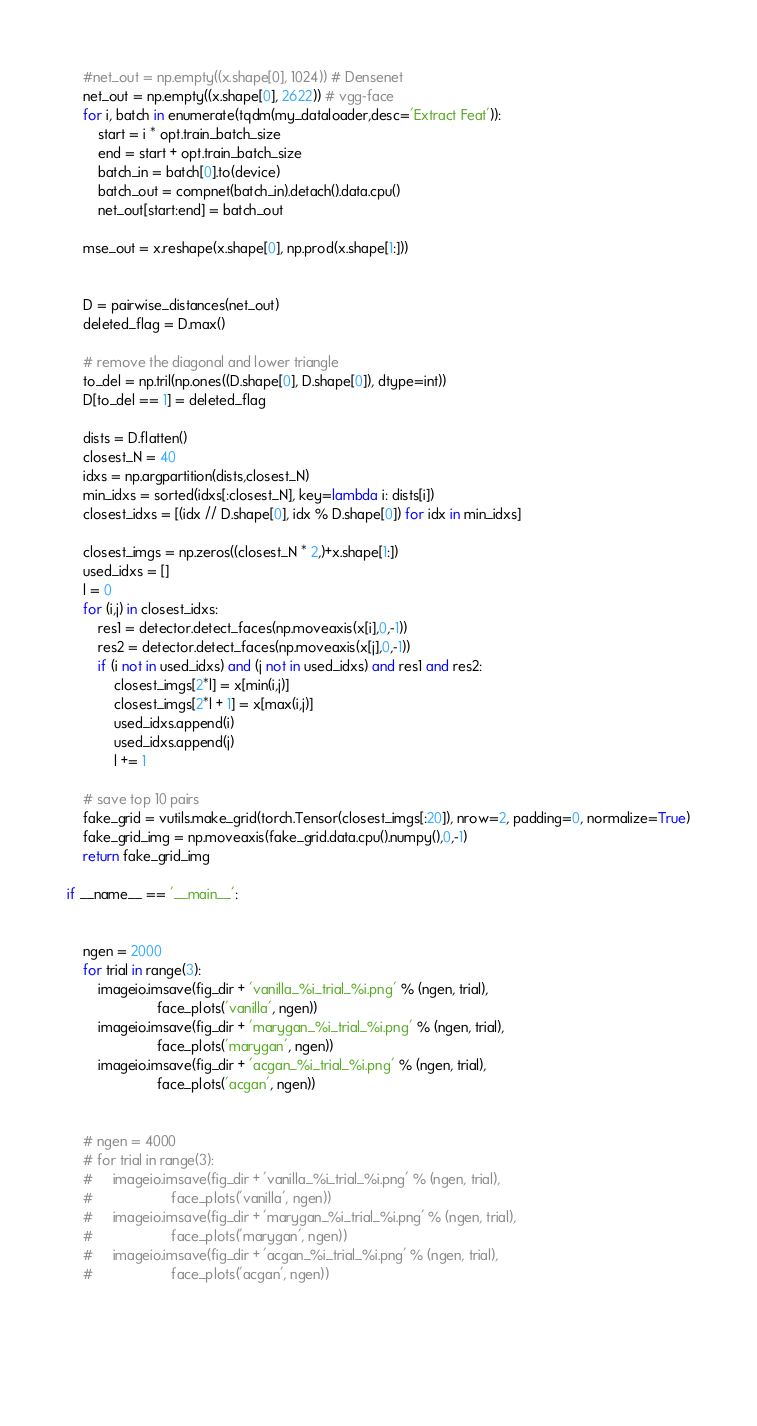Convert code to text. <code><loc_0><loc_0><loc_500><loc_500><_Python_>    #net_out = np.empty((x.shape[0], 1024)) # Densenet
    net_out = np.empty((x.shape[0], 2622)) # vgg-face
    for i, batch in enumerate(tqdm(my_dataloader,desc='Extract Feat')):
        start = i * opt.train_batch_size
        end = start + opt.train_batch_size
        batch_in = batch[0].to(device)
        batch_out = compnet(batch_in).detach().data.cpu()
        net_out[start:end] = batch_out

    mse_out = x.reshape(x.shape[0], np.prod(x.shape[1:]))
    

    D = pairwise_distances(net_out)
    deleted_flag = D.max()

    # remove the diagonal and lower triangle
    to_del = np.tril(np.ones((D.shape[0], D.shape[0]), dtype=int))
    D[to_del == 1] = deleted_flag

    dists = D.flatten()
    closest_N = 40
    idxs = np.argpartition(dists,closest_N)
    min_idxs = sorted(idxs[:closest_N], key=lambda i: dists[i])
    closest_idxs = [(idx // D.shape[0], idx % D.shape[0]) for idx in min_idxs]

    closest_imgs = np.zeros((closest_N * 2,)+x.shape[1:])
    used_idxs = []
    l = 0
    for (i,j) in closest_idxs:
        res1 = detector.detect_faces(np.moveaxis(x[i],0,-1))
        res2 = detector.detect_faces(np.moveaxis(x[j],0,-1))
        if (i not in used_idxs) and (j not in used_idxs) and res1 and res2:
            closest_imgs[2*l] = x[min(i,j)]
            closest_imgs[2*l + 1] = x[max(i,j)]
            used_idxs.append(i)
            used_idxs.append(j)
            l += 1

    # save top 10 pairs
    fake_grid = vutils.make_grid(torch.Tensor(closest_imgs[:20]), nrow=2, padding=0, normalize=True)
    fake_grid_img = np.moveaxis(fake_grid.data.cpu().numpy(),0,-1)
    return fake_grid_img

if __name__ == '__main__':


    ngen = 2000
    for trial in range(3):
        imageio.imsave(fig_dir + 'vanilla_%i_trial_%i.png' % (ngen, trial),
                       face_plots('vanilla', ngen))
        imageio.imsave(fig_dir + 'marygan_%i_trial_%i.png' % (ngen, trial),
                       face_plots('marygan', ngen))
        imageio.imsave(fig_dir + 'acgan_%i_trial_%i.png' % (ngen, trial),
                       face_plots('acgan', ngen))


    # ngen = 4000
    # for trial in range(3):
    #     imageio.imsave(fig_dir + 'vanilla_%i_trial_%i.png' % (ngen, trial),
    #                    face_plots('vanilla', ngen))
    #     imageio.imsave(fig_dir + 'marygan_%i_trial_%i.png' % (ngen, trial),
    #                    face_plots('marygan', ngen))
    #     imageio.imsave(fig_dir + 'acgan_%i_trial_%i.png' % (ngen, trial),
    #                    face_plots('acgan', ngen))



    

</code> 